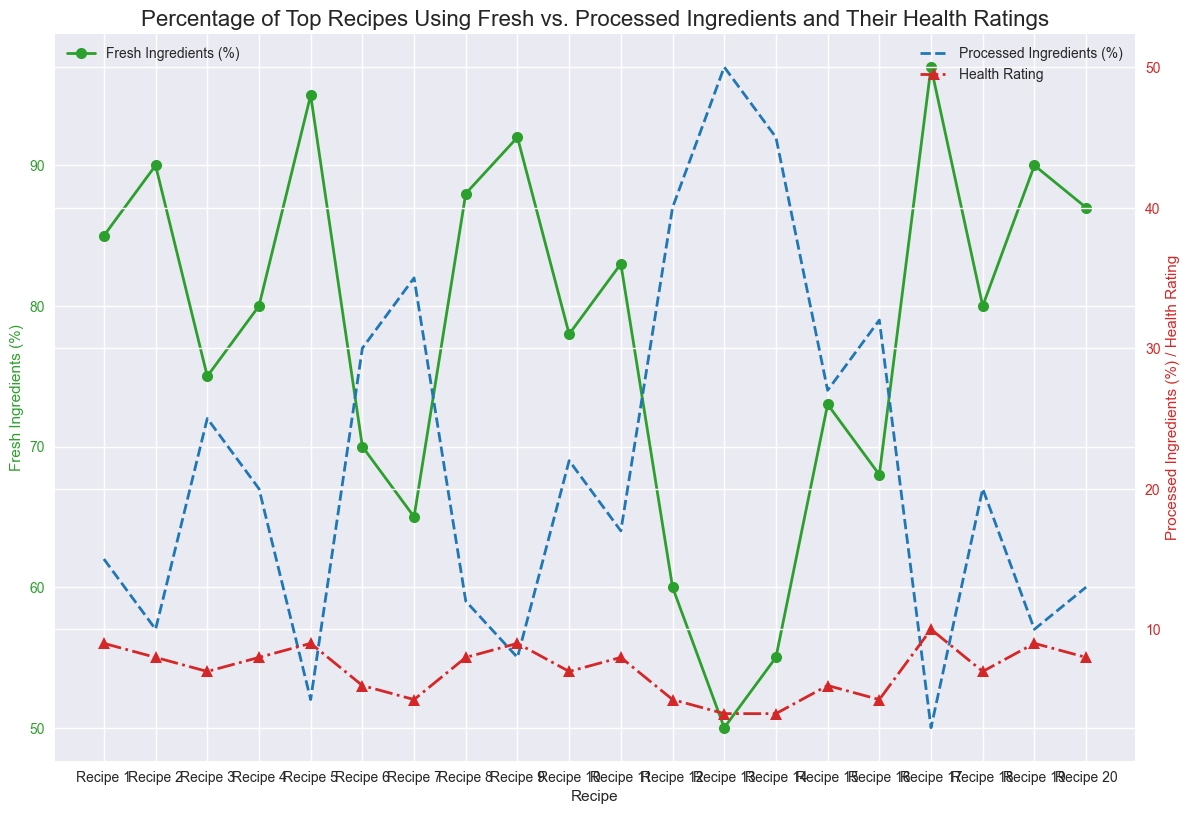What is the range of Fresh Ingredients (%) used in the recipes? The Fresh Ingredients (%) data in the figure ranges from the highest value to the lowest value. Observing the graph, the highest Fresh Ingredients (%) is 97 for Recipe 17 and the lowest is 50 for Recipe 13.
Answer: 50 to 97 Which recipe has the highest Health Rating? The line representing Health Rating peaks at Recipe 17 where the Health Rating is 10.
Answer: Recipe 17 How many recipes use more than 80% Fresh Ingredients? Recipes with Fresh Ingredients (%) above 80 appear as upward spikes in the green line. Counting these spikes, we find Recipes 1, 2, 5, 8, 9, 17, 19, and 20, which total 8 recipes.
Answer: 8 What is the average Health Rating for recipes using more than 90% Fresh Ingredients? Recipes with more than 90% Fresh Ingredients are Recipes 2, 5, 9, 17, and 19. Their Health Ratings are 8, 9, 9, 10, and 9. Summing these gives 8 + 9 + 9 + 10 + 9 = 45, and there are 5 such recipes. The average is 45/5 = 9.
Answer: 9 What color represents Processed Ingredients (%) in the chart? In the graph, the blue dashed line with 'x' markers represents Processed Ingredients (%).
Answer: Blue Comparing Recipe 6 and Recipe 16, which has a higher percentage of Processed Ingredients (%)? Observing Processed Ingredients (%) for Recipe 6 and 16, Recipe 6 has 30%, and Recipe 16 has 32%. Hence, Recipe 16 has a higher percentage.
Answer: Recipe 16 Which recipes have a Health Rating higher than 8? Observing the recipes with Health Ratings greater than 8, only Recipes 1, 5, 9, 17, and 19 have ratings of 9, 9, 9, 10, and 9 respectively.
Answer: Recipes 1, 5, 9, 17, and 19 Identify the color representing Health Rating in the graph. The line for Health Rating in the graph is red with '^' markers.
Answer: Red What is the sum of the Health Ratings for recipes that use less than 60% Fresh Ingredients? The recipes with less than 60% Fresh Ingredients are Recipes 12, 13, and 14 with Health Ratings 5, 4, and 4 respectively. Summing these gives 5 + 4 + 4 = 13.
Answer: 13 Which recipe has the largest difference between Fresh and Processed Ingredients (%)? Finding the differences between Fresh Ingredients (%) and Processed Ingredients (%) for each recipe, Recipe 17 has the largest difference with 97% Fresh and 3% Processed Ingredients, a difference of 94%.
Answer: Recipe 17 